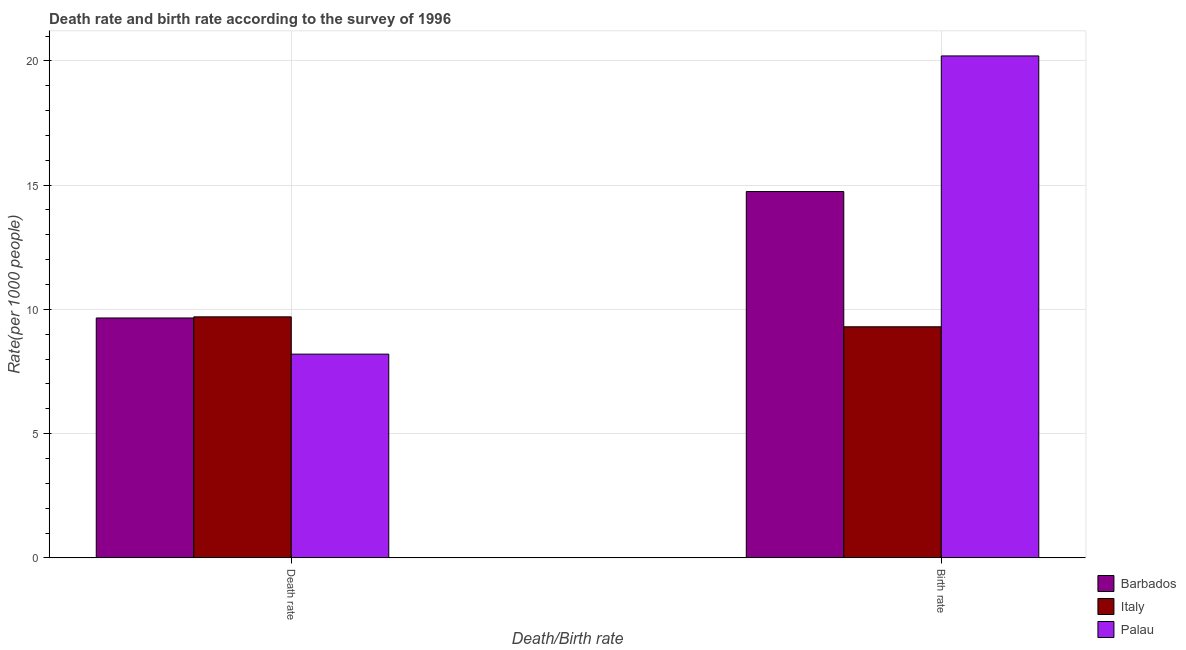How many groups of bars are there?
Your answer should be compact. 2. Are the number of bars per tick equal to the number of legend labels?
Your answer should be compact. Yes. Are the number of bars on each tick of the X-axis equal?
Your response must be concise. Yes. What is the label of the 1st group of bars from the left?
Your response must be concise. Death rate. What is the birth rate in Barbados?
Offer a terse response. 14.74. In which country was the birth rate maximum?
Provide a succinct answer. Palau. What is the total birth rate in the graph?
Ensure brevity in your answer.  44.24. What is the difference between the death rate in Barbados and that in Italy?
Your answer should be compact. -0.04. What is the difference between the death rate in Barbados and the birth rate in Palau?
Offer a terse response. -10.54. What is the average death rate per country?
Provide a short and direct response. 9.18. What is the difference between the death rate and birth rate in Italy?
Provide a short and direct response. 0.4. In how many countries, is the death rate greater than 11 ?
Your answer should be very brief. 0. What is the ratio of the death rate in Italy to that in Palau?
Your answer should be very brief. 1.18. Is the death rate in Barbados less than that in Palau?
Offer a terse response. No. What does the 3rd bar from the left in Birth rate represents?
Offer a terse response. Palau. What does the 2nd bar from the right in Death rate represents?
Provide a short and direct response. Italy. How many bars are there?
Your answer should be compact. 6. How many countries are there in the graph?
Offer a very short reply. 3. Does the graph contain grids?
Make the answer very short. Yes. Where does the legend appear in the graph?
Keep it short and to the point. Bottom right. How many legend labels are there?
Provide a succinct answer. 3. How are the legend labels stacked?
Your answer should be compact. Vertical. What is the title of the graph?
Make the answer very short. Death rate and birth rate according to the survey of 1996. What is the label or title of the X-axis?
Give a very brief answer. Death/Birth rate. What is the label or title of the Y-axis?
Give a very brief answer. Rate(per 1000 people). What is the Rate(per 1000 people) in Barbados in Death rate?
Keep it short and to the point. 9.65. What is the Rate(per 1000 people) of Italy in Death rate?
Keep it short and to the point. 9.7. What is the Rate(per 1000 people) of Barbados in Birth rate?
Your answer should be compact. 14.74. What is the Rate(per 1000 people) in Italy in Birth rate?
Provide a short and direct response. 9.3. What is the Rate(per 1000 people) in Palau in Birth rate?
Give a very brief answer. 20.2. Across all Death/Birth rate, what is the maximum Rate(per 1000 people) of Barbados?
Provide a succinct answer. 14.74. Across all Death/Birth rate, what is the maximum Rate(per 1000 people) of Palau?
Ensure brevity in your answer.  20.2. Across all Death/Birth rate, what is the minimum Rate(per 1000 people) in Barbados?
Offer a terse response. 9.65. What is the total Rate(per 1000 people) in Barbados in the graph?
Provide a succinct answer. 24.4. What is the total Rate(per 1000 people) of Palau in the graph?
Ensure brevity in your answer.  28.4. What is the difference between the Rate(per 1000 people) in Barbados in Death rate and that in Birth rate?
Your response must be concise. -5.09. What is the difference between the Rate(per 1000 people) in Palau in Death rate and that in Birth rate?
Make the answer very short. -12. What is the difference between the Rate(per 1000 people) in Barbados in Death rate and the Rate(per 1000 people) in Italy in Birth rate?
Your response must be concise. 0.35. What is the difference between the Rate(per 1000 people) in Barbados in Death rate and the Rate(per 1000 people) in Palau in Birth rate?
Make the answer very short. -10.54. What is the average Rate(per 1000 people) of Barbados per Death/Birth rate?
Keep it short and to the point. 12.2. What is the difference between the Rate(per 1000 people) in Barbados and Rate(per 1000 people) in Italy in Death rate?
Provide a succinct answer. -0.04. What is the difference between the Rate(per 1000 people) of Barbados and Rate(per 1000 people) of Palau in Death rate?
Your response must be concise. 1.46. What is the difference between the Rate(per 1000 people) in Italy and Rate(per 1000 people) in Palau in Death rate?
Offer a very short reply. 1.5. What is the difference between the Rate(per 1000 people) in Barbados and Rate(per 1000 people) in Italy in Birth rate?
Offer a terse response. 5.44. What is the difference between the Rate(per 1000 people) of Barbados and Rate(per 1000 people) of Palau in Birth rate?
Your answer should be compact. -5.46. What is the ratio of the Rate(per 1000 people) in Barbados in Death rate to that in Birth rate?
Make the answer very short. 0.65. What is the ratio of the Rate(per 1000 people) in Italy in Death rate to that in Birth rate?
Your answer should be very brief. 1.04. What is the ratio of the Rate(per 1000 people) in Palau in Death rate to that in Birth rate?
Your answer should be compact. 0.41. What is the difference between the highest and the second highest Rate(per 1000 people) of Barbados?
Give a very brief answer. 5.09. What is the difference between the highest and the second highest Rate(per 1000 people) in Italy?
Your answer should be compact. 0.4. What is the difference between the highest and the second highest Rate(per 1000 people) of Palau?
Provide a succinct answer. 12. What is the difference between the highest and the lowest Rate(per 1000 people) in Barbados?
Your response must be concise. 5.09. What is the difference between the highest and the lowest Rate(per 1000 people) of Italy?
Your answer should be compact. 0.4. What is the difference between the highest and the lowest Rate(per 1000 people) in Palau?
Your response must be concise. 12. 